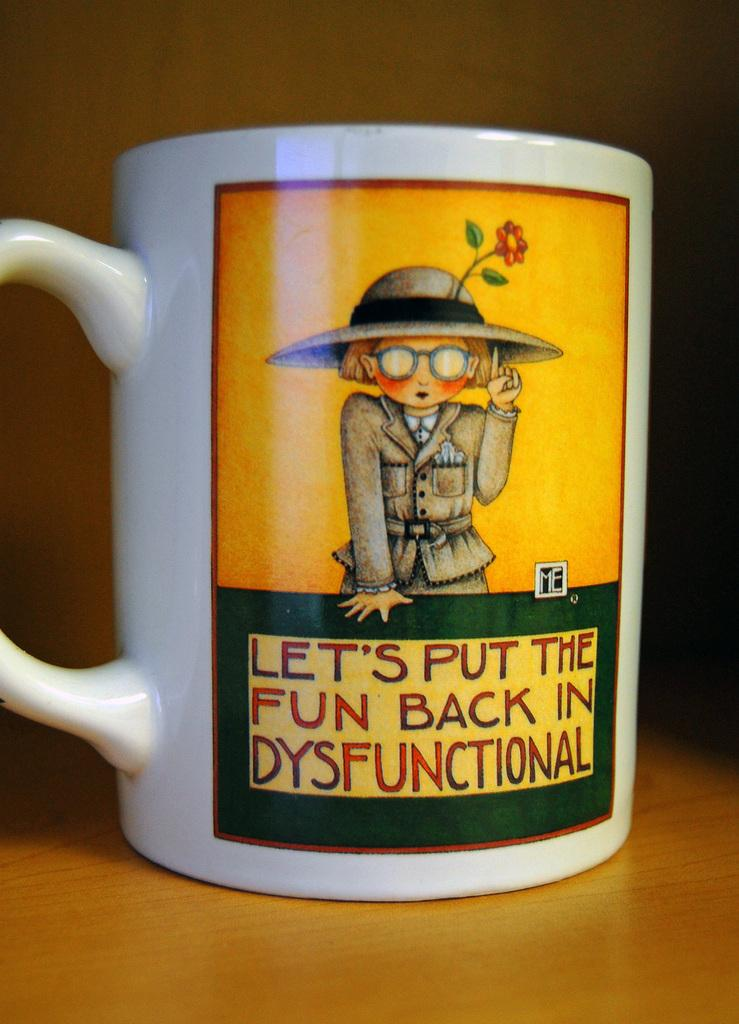What object is on the table in the image? There is a cup on the table in the image. What is depicted on the cup? The cup has a picture of a person and a picture of a flower. Are there any words on the cup? Yes, there is text on the cup. What type of rod can be seen holding up the flower in the image? There is no rod holding up the flower in the image; the flower is depicted on the cup. 